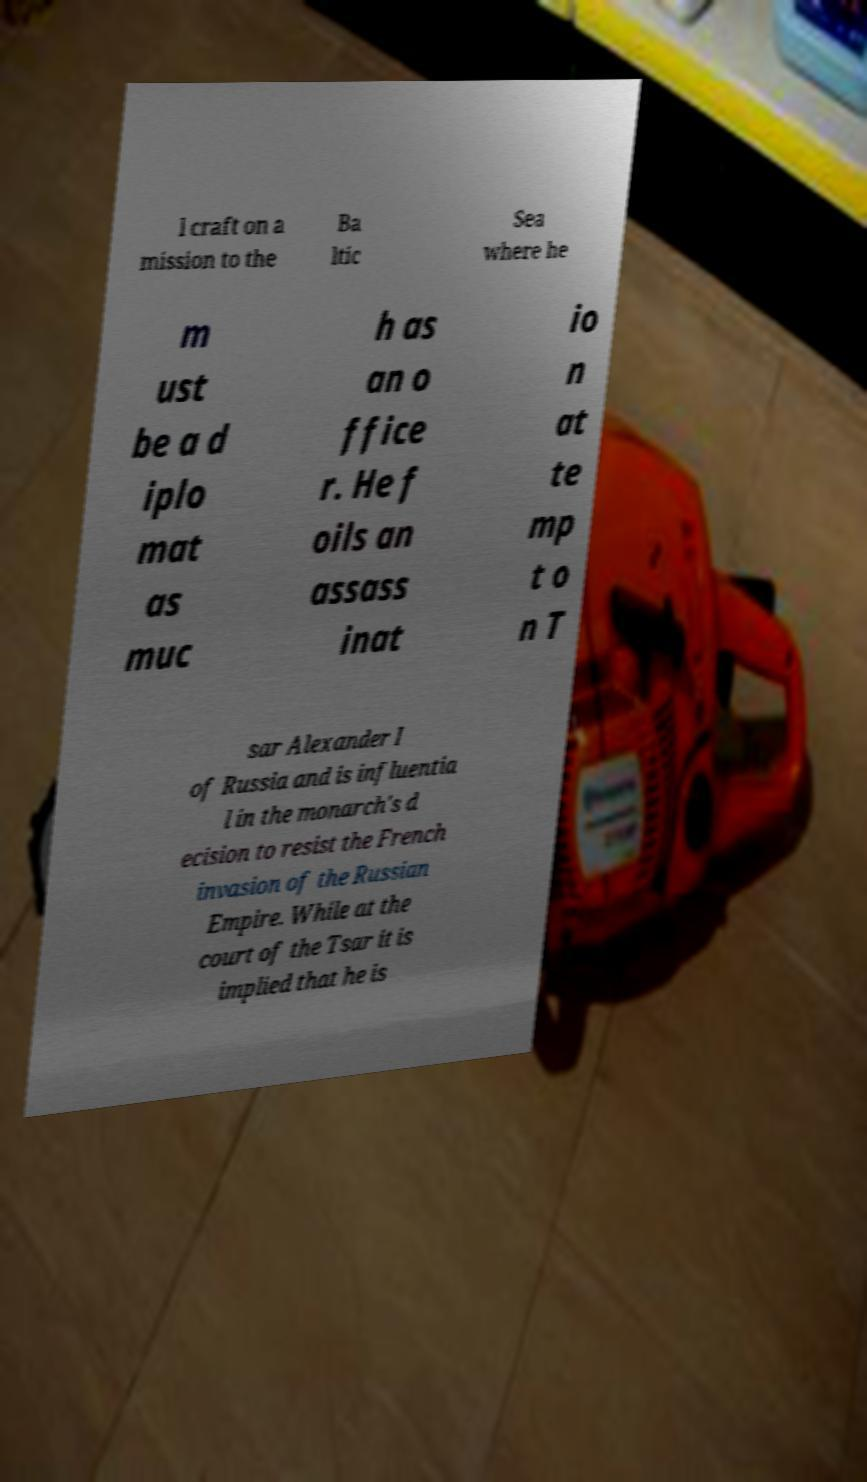Could you extract and type out the text from this image? l craft on a mission to the Ba ltic Sea where he m ust be a d iplo mat as muc h as an o ffice r. He f oils an assass inat io n at te mp t o n T sar Alexander I of Russia and is influentia l in the monarch's d ecision to resist the French invasion of the Russian Empire. While at the court of the Tsar it is implied that he is 